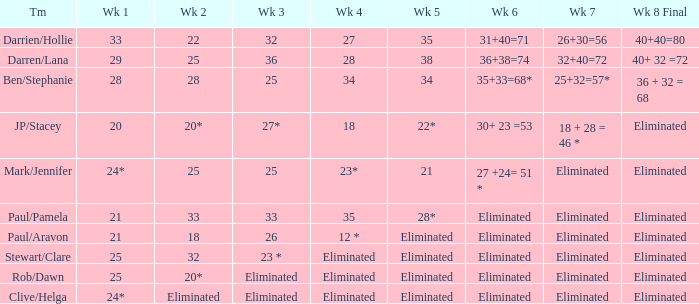Name the week 6 when week 3 is 25 and week 7 is eliminated 27 +24= 51 *. 